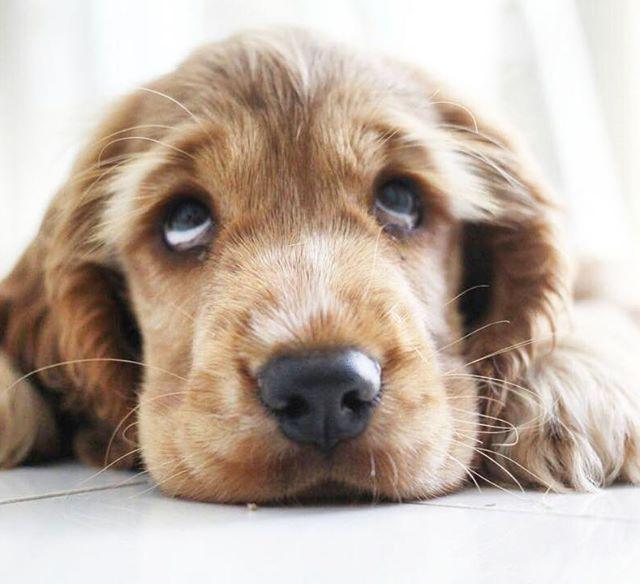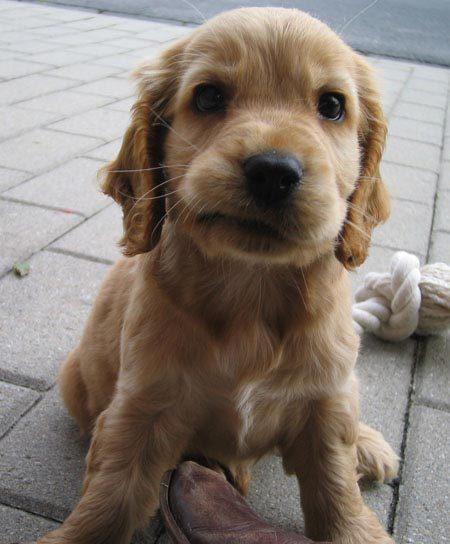The first image is the image on the left, the second image is the image on the right. Evaluate the accuracy of this statement regarding the images: "There are equal amount of dogs on the left image as the right image.". Is it true? Answer yes or no. Yes. The first image is the image on the left, the second image is the image on the right. Assess this claim about the two images: "There are at least three dogs in the right image.". Correct or not? Answer yes or no. No. 